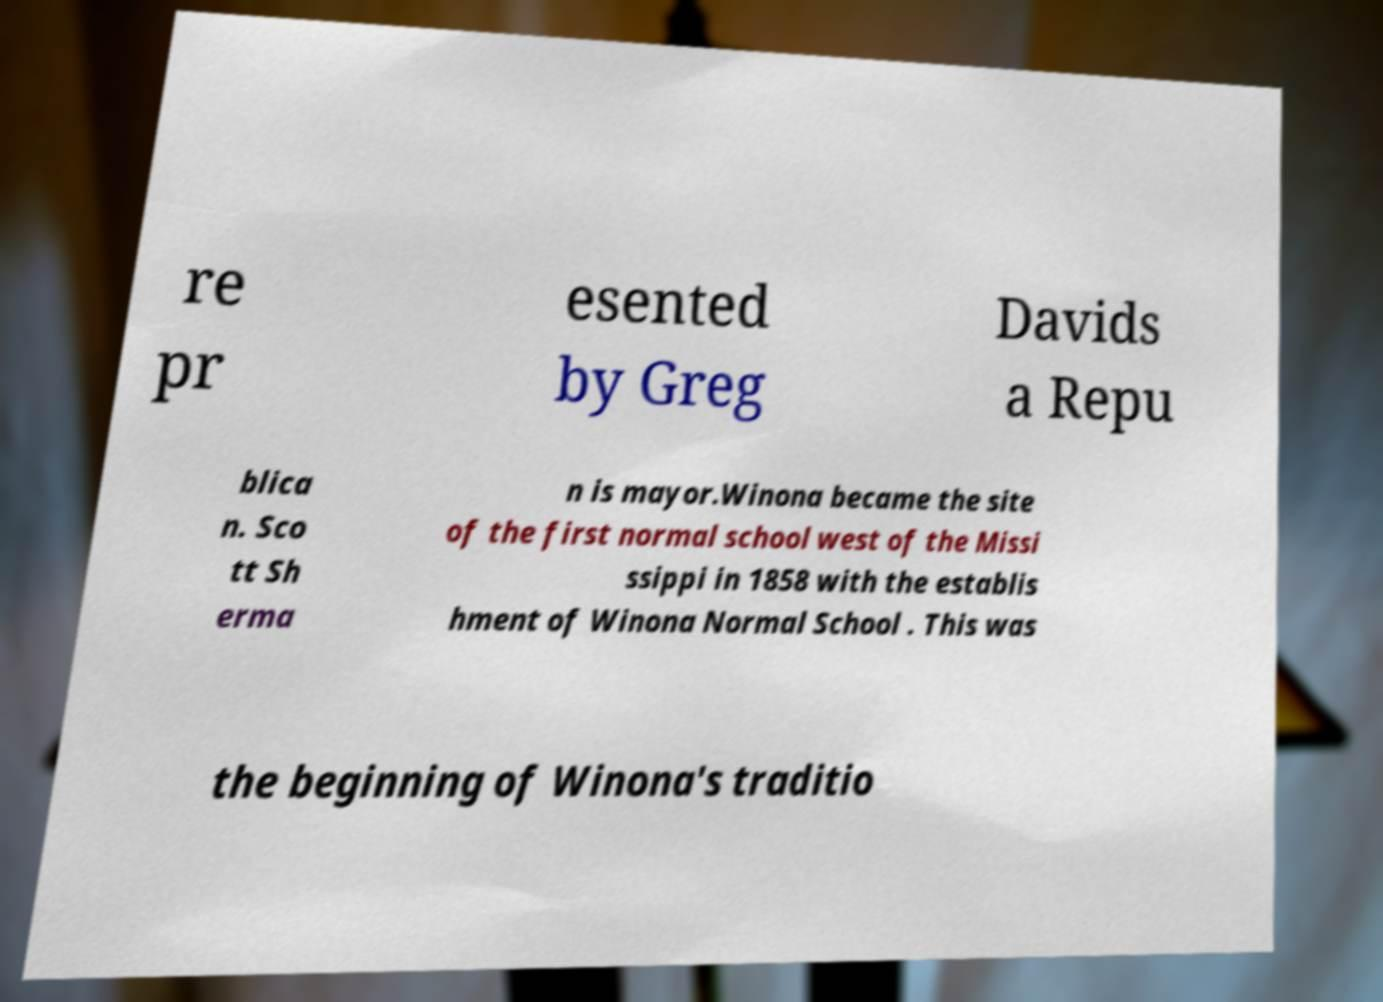Please identify and transcribe the text found in this image. re pr esented by Greg Davids a Repu blica n. Sco tt Sh erma n is mayor.Winona became the site of the first normal school west of the Missi ssippi in 1858 with the establis hment of Winona Normal School . This was the beginning of Winona's traditio 